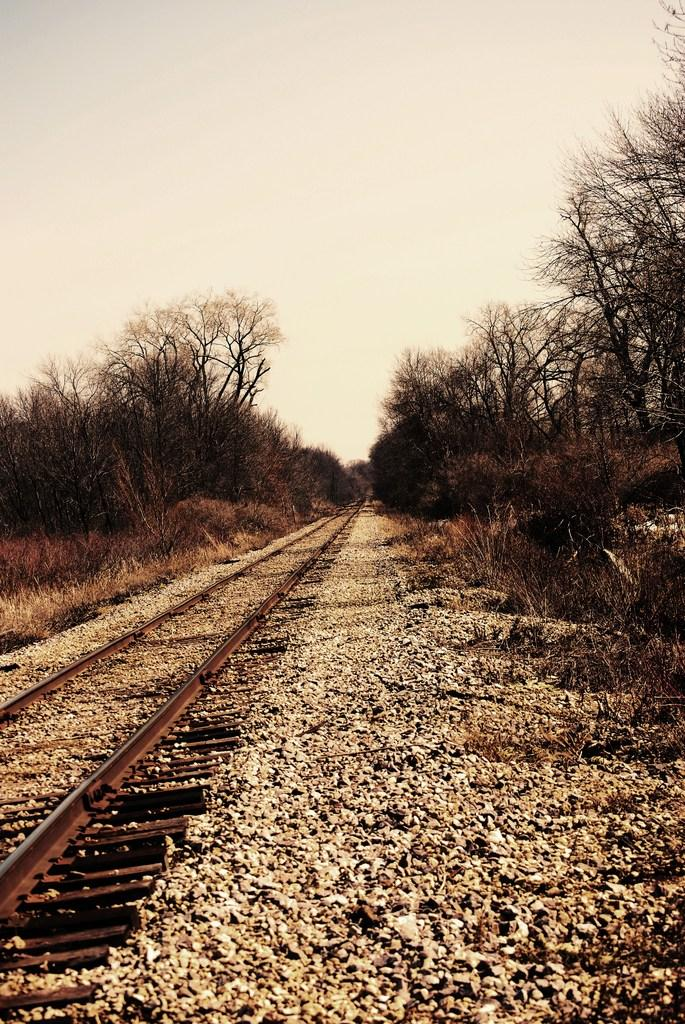What type of transportation infrastructure is visible in the image? There is a railway track in the image. What natural elements can be seen in the image? There are trees in the image. What is visible at the top of the image? The sky is visible at the top of the image. Where is the daughter sitting with her cup in the image? There is no daughter or cup present in the image. What type of bird's nest can be seen in the trees in the image? There is no bird's nest visible in the image; only trees are present. 